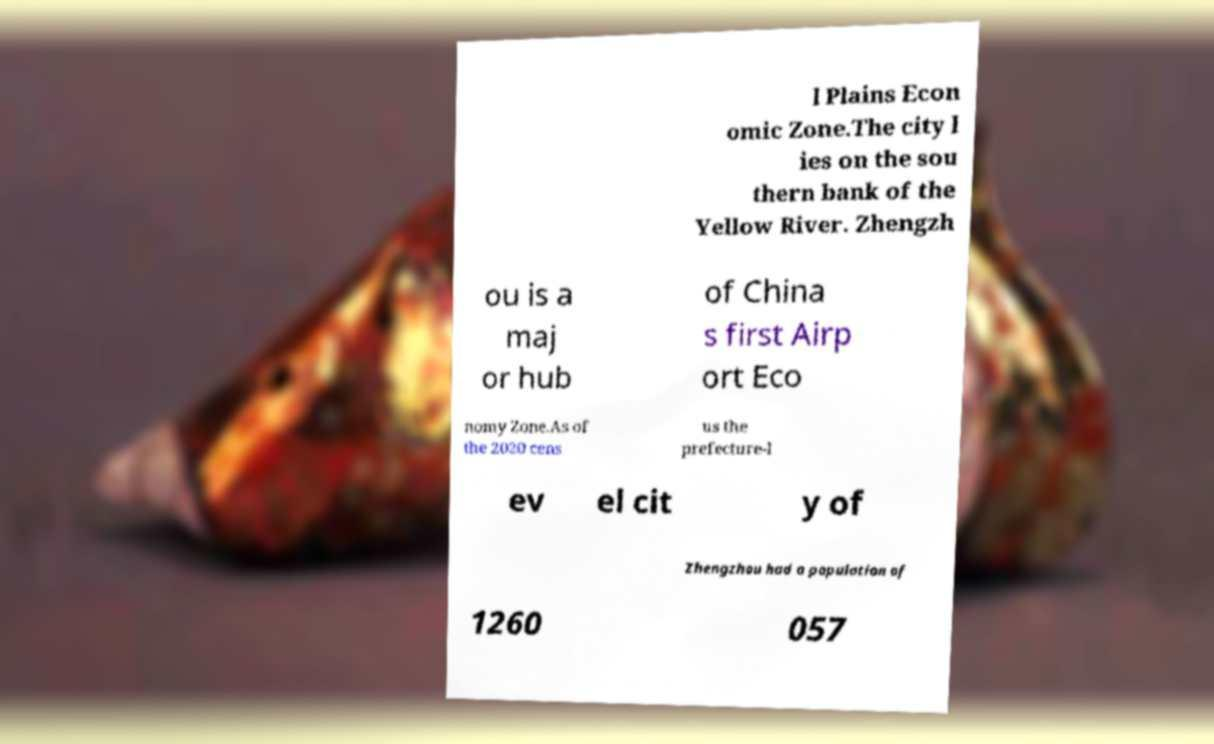Please read and relay the text visible in this image. What does it say? l Plains Econ omic Zone.The city l ies on the sou thern bank of the Yellow River. Zhengzh ou is a maj or hub of China s first Airp ort Eco nomy Zone.As of the 2020 cens us the prefecture-l ev el cit y of Zhengzhou had a population of 1260 057 